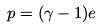<formula> <loc_0><loc_0><loc_500><loc_500>p = ( \gamma - 1 ) e \,</formula> 